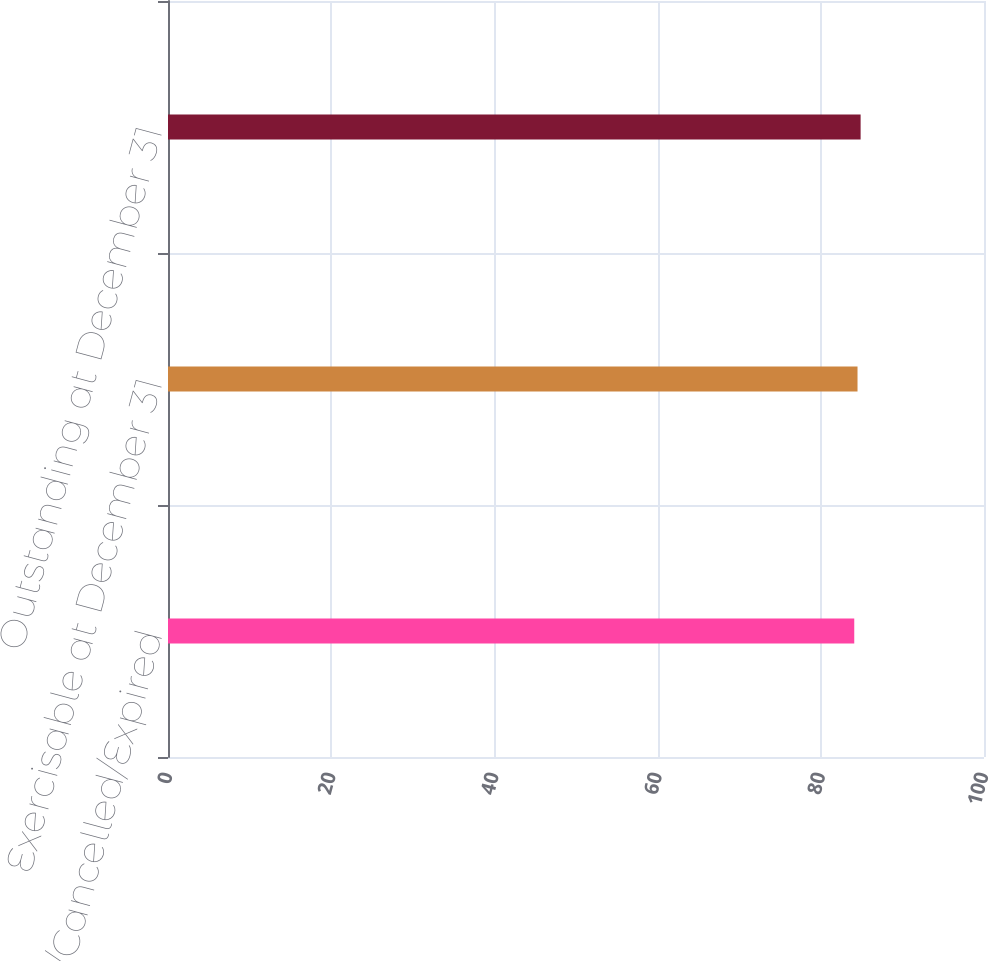Convert chart. <chart><loc_0><loc_0><loc_500><loc_500><bar_chart><fcel>Forfeited/Cancelled/Expired<fcel>Exercisable at December 31<fcel>Outstanding at December 31<nl><fcel>84.1<fcel>84.5<fcel>84.88<nl></chart> 